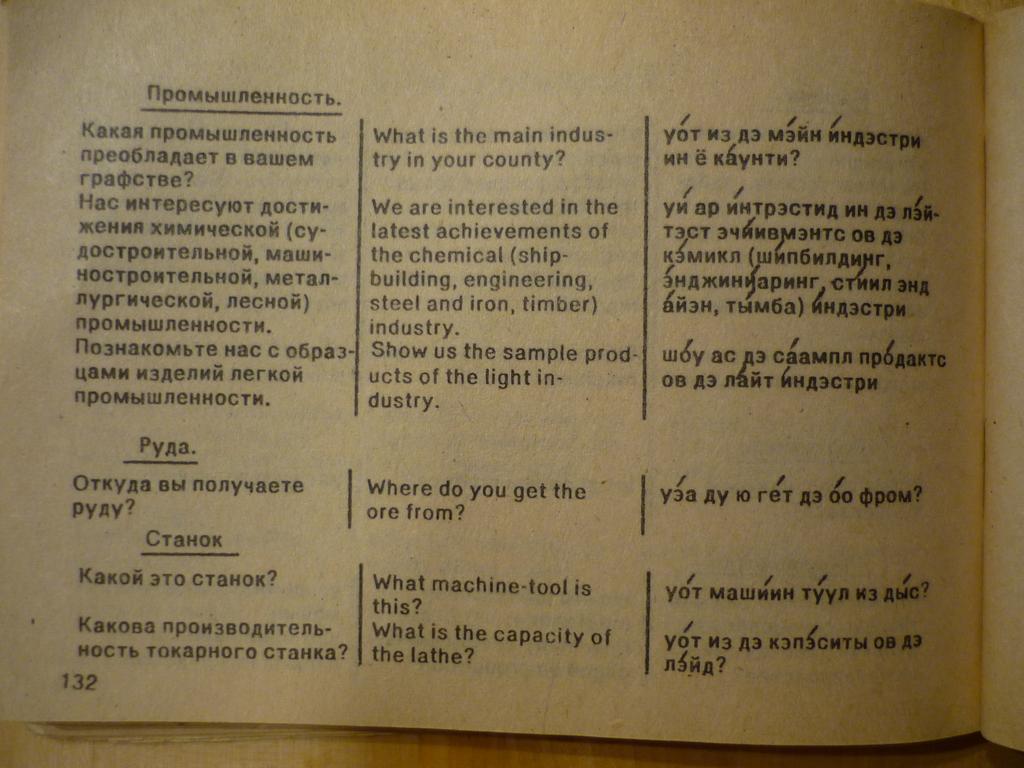What does the sentence in the top center of the page say?
Offer a very short reply. What is the main industry in your country?. 